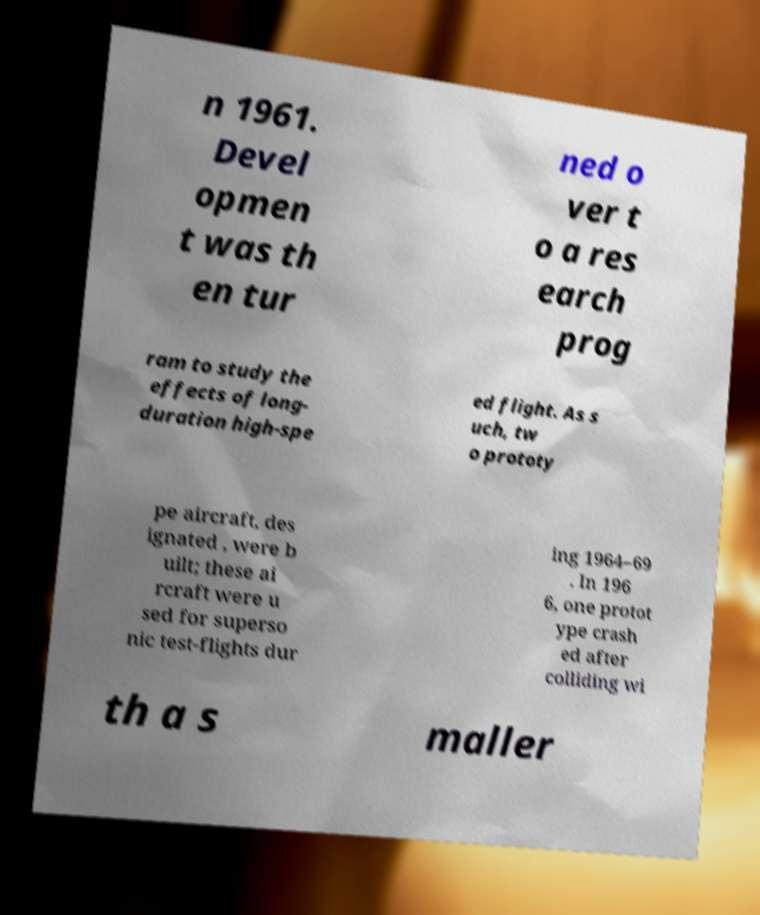Can you read and provide the text displayed in the image?This photo seems to have some interesting text. Can you extract and type it out for me? n 1961. Devel opmen t was th en tur ned o ver t o a res earch prog ram to study the effects of long- duration high-spe ed flight. As s uch, tw o prototy pe aircraft, des ignated , were b uilt; these ai rcraft were u sed for superso nic test-flights dur ing 1964–69 . In 196 6, one protot ype crash ed after colliding wi th a s maller 